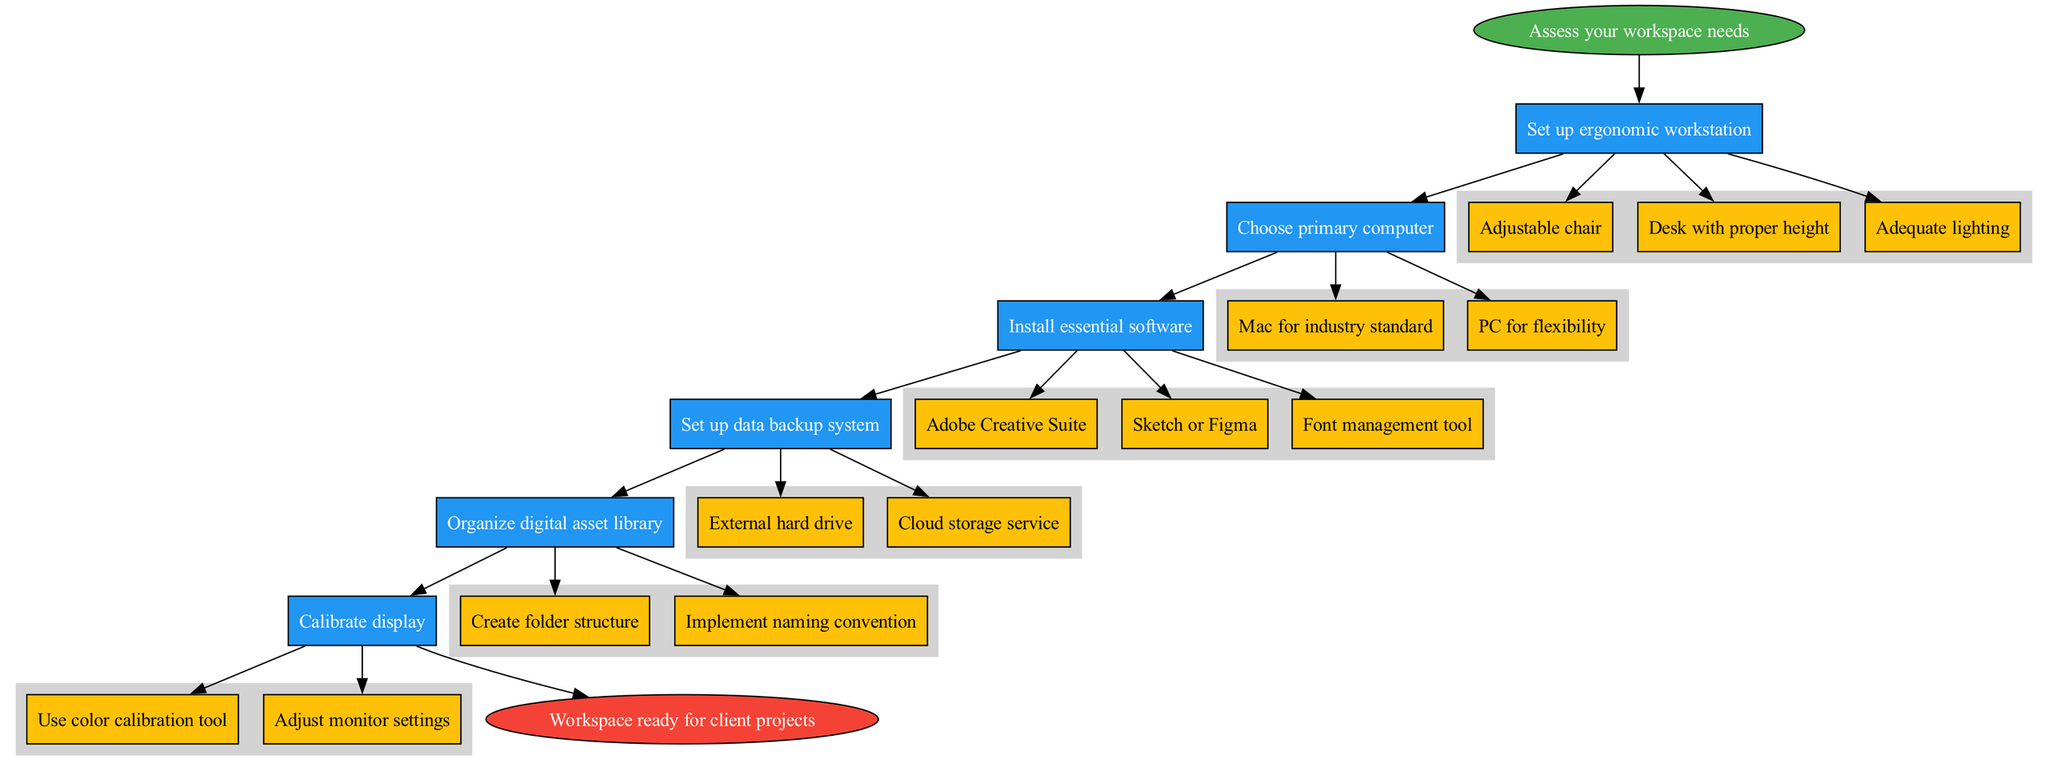What is the starting point of setting up a professional graphic design workspace? The diagram begins with "Assess your workspace needs" as the first step. This is indicated visually as the starting node in the flow chart.
Answer: Assess your workspace needs How many main steps are there in the diagram? The main steps are represented as individual nodes between the starting and ending points. Counting these nodes shows that there are six main steps in total.
Answer: 6 What are the two primary computer options listed? The step "Choose primary computer" shows two options: "Mac for industry standard" and "PC for flexibility". These are listed as sub-steps under this main step in the flow chart.
Answer: Mac for industry standard, PC for flexibility What is the last action to take before completing the workspace setup? The final node before the end of the diagram is "Calibrate display". This indicates the last action that should be performed to finalize the workspace setup.
Answer: Calibrate display What is necessary to install as essential software? The diagram outlines three essential software packages to install under the "Install essential software" step: "Adobe Creative Suite", "Sketch or Figma", and "Font management tool".
Answer: Adobe Creative Suite, Sketch or Figma, Font management tool How do you set up a data backup system? In the step "Set up data backup system", two methods are provided: "External hard drive" and "Cloud storage service". These methods are linked as options to ensure data safety and availability.
Answer: External hard drive, Cloud storage service Which node precedes "Organize digital asset library"? Observing the flow of the diagram, the step "Set up data backup system" is followed by "Organize digital asset library". This means that you must complete the backup setup to proceed to organizing assets.
Answer: Set up data backup system Which sub-step is recommended for display calibration? The sub-step under "Calibrate display" that suggests a method is "Use color calibration tool". This visually indicates a specific action to achieve proper display settings.
Answer: Use color calibration tool 